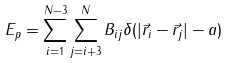<formula> <loc_0><loc_0><loc_500><loc_500>E _ { p } = \sum _ { i = 1 } ^ { N - 3 } \sum _ { j = i + 3 } ^ { N } B _ { i j } \delta ( | \vec { r } _ { i } - \vec { r } _ { j } | - a )</formula> 